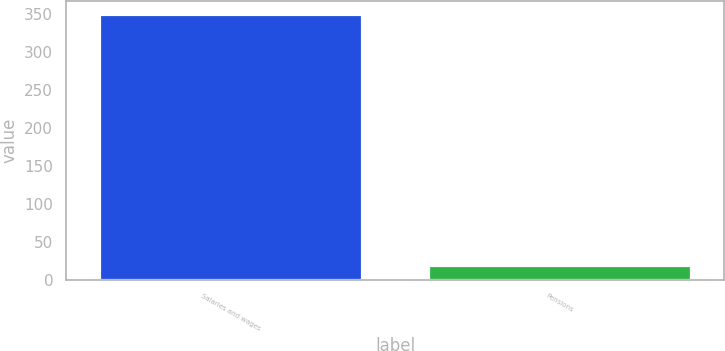Convert chart to OTSL. <chart><loc_0><loc_0><loc_500><loc_500><bar_chart><fcel>Salaries and wages<fcel>Pensions<nl><fcel>349<fcel>19<nl></chart> 